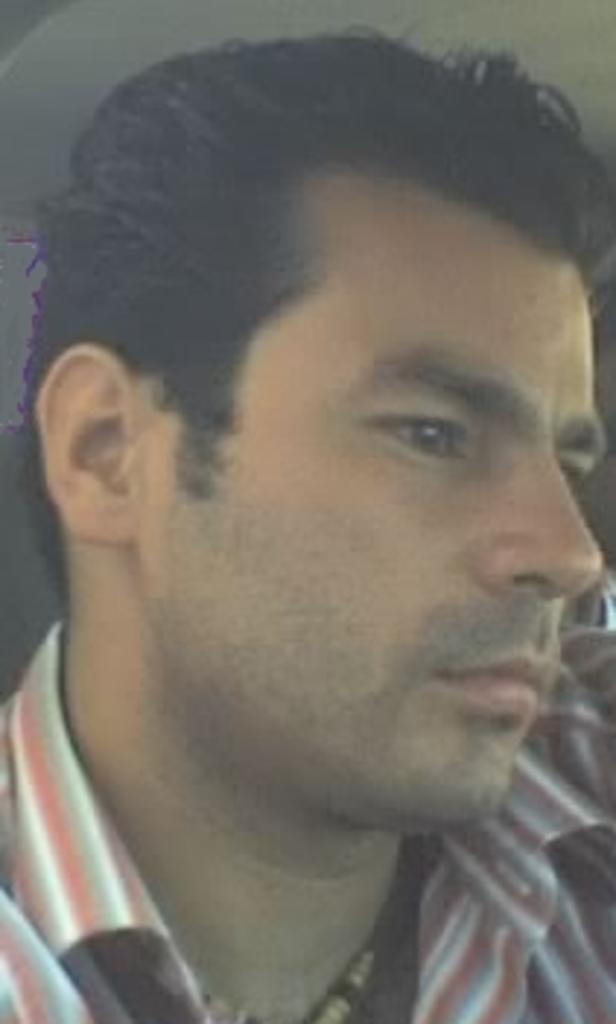What is the main subject of the image? The main subject of the image is a person's face. What is the person wearing in the image? The person is wearing a shirt in the image. How many frogs are sitting on the person's head in the image? There are no frogs present in the image. What color are the lizards on the person's shirt in the image? There are no lizards present on the person's shirt in the image. 